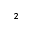<formula> <loc_0><loc_0><loc_500><loc_500>^ { 2 }</formula> 